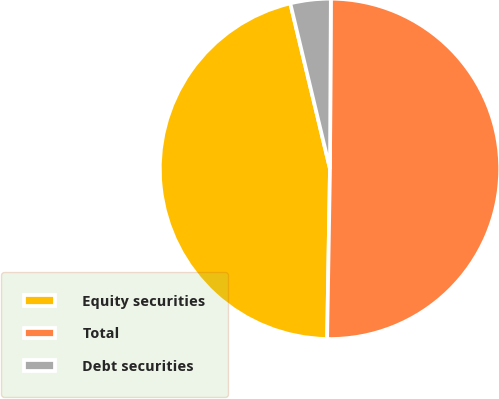Convert chart. <chart><loc_0><loc_0><loc_500><loc_500><pie_chart><fcel>Equity securities<fcel>Total<fcel>Debt securities<nl><fcel>45.98%<fcel>50.19%<fcel>3.83%<nl></chart> 